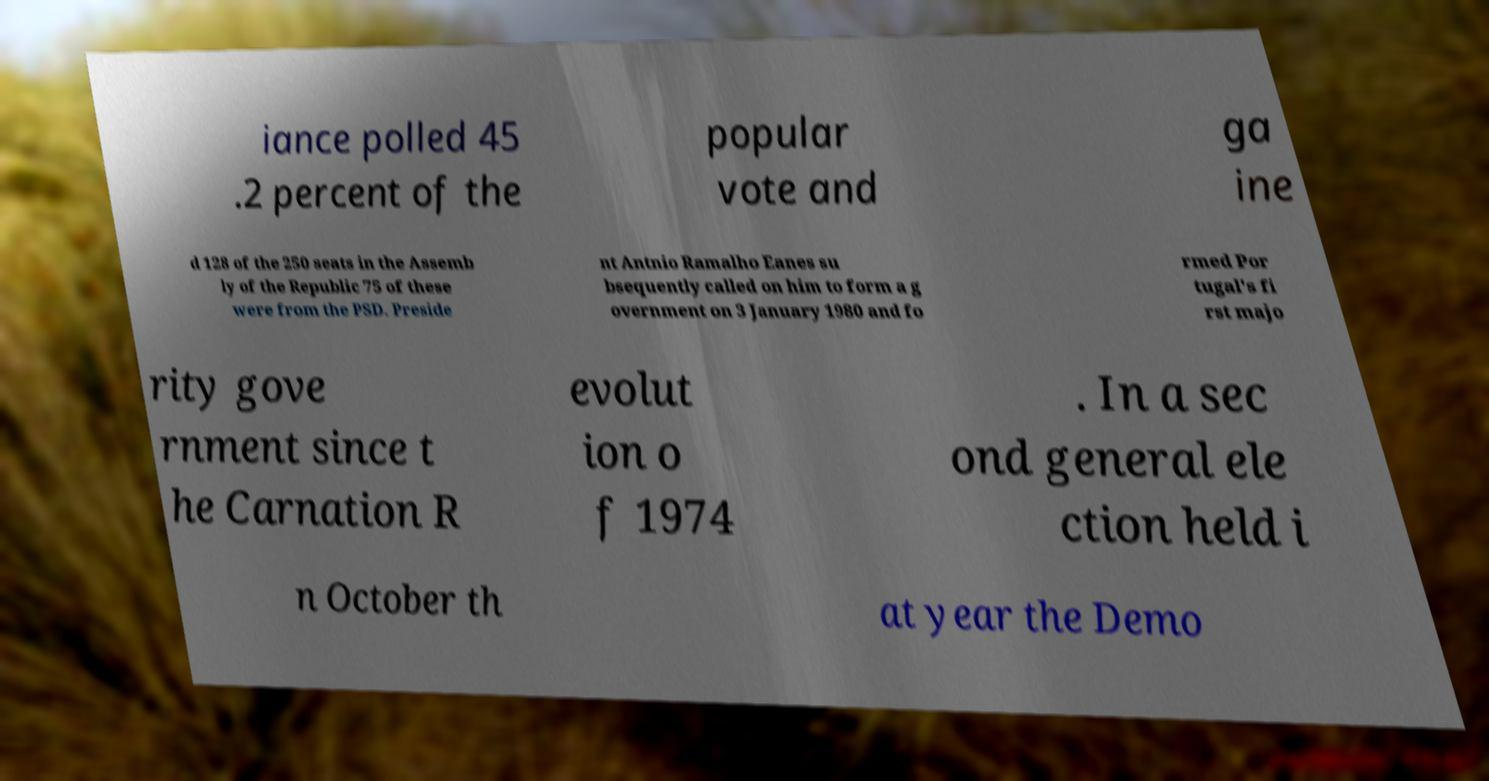There's text embedded in this image that I need extracted. Can you transcribe it verbatim? iance polled 45 .2 percent of the popular vote and ga ine d 128 of the 250 seats in the Assemb ly of the Republic 75 of these were from the PSD. Preside nt Antnio Ramalho Eanes su bsequently called on him to form a g overnment on 3 January 1980 and fo rmed Por tugal's fi rst majo rity gove rnment since t he Carnation R evolut ion o f 1974 . In a sec ond general ele ction held i n October th at year the Demo 